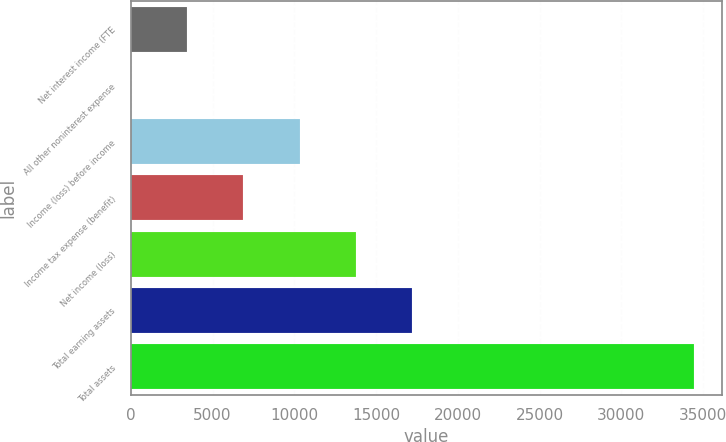<chart> <loc_0><loc_0><loc_500><loc_500><bar_chart><fcel>Net interest income (FTE<fcel>All other noninterest expense<fcel>Income (loss) before income<fcel>Income tax expense (benefit)<fcel>Net income (loss)<fcel>Total earning assets<fcel>Total assets<nl><fcel>3445.1<fcel>1<fcel>10333.3<fcel>6889.2<fcel>13777.4<fcel>17221.5<fcel>34442<nl></chart> 